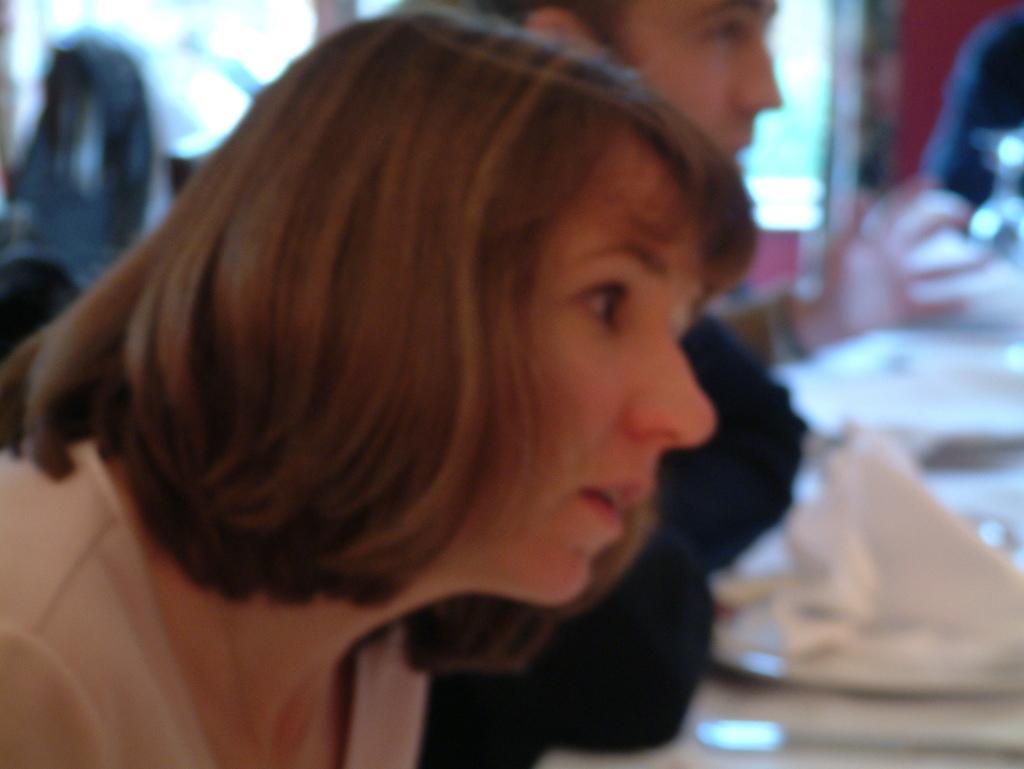Can you describe this image briefly? In the picture I can see a woman and there is a person beside her and there are few other objects in the background. 